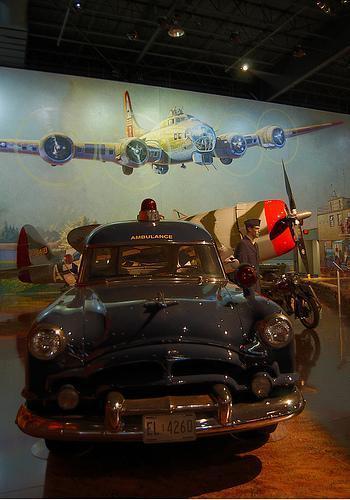How many cars are in the picture?
Give a very brief answer. 1. How many planes are in the picture?
Give a very brief answer. 2. 